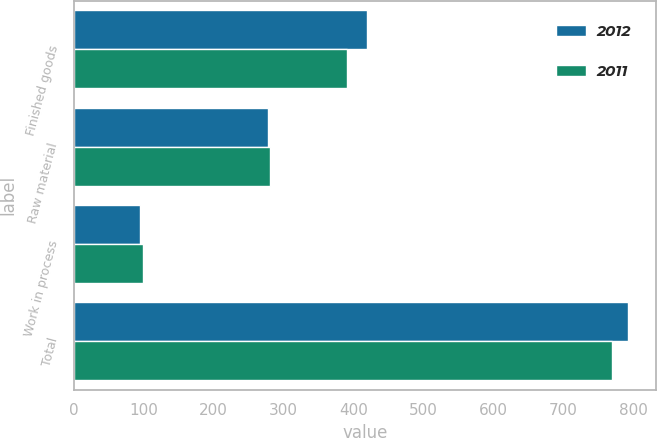Convert chart to OTSL. <chart><loc_0><loc_0><loc_500><loc_500><stacked_bar_chart><ecel><fcel>Finished goods<fcel>Raw material<fcel>Work in process<fcel>Total<nl><fcel>2012<fcel>419<fcel>278<fcel>95<fcel>792<nl><fcel>2011<fcel>390<fcel>280<fcel>99<fcel>769<nl></chart> 